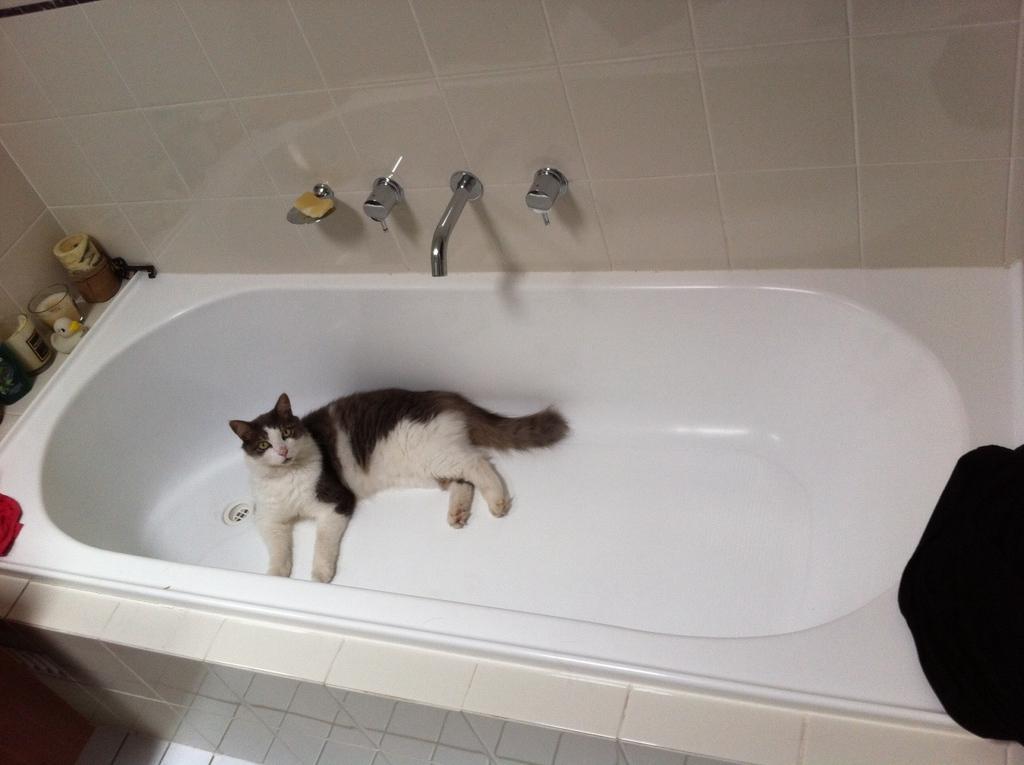Please provide a concise description of this image. In this image we can see a cat in the bathtub. We can see objects on the left side of the image. There is a black color object on the right side of the image. At the top of the image, we can see a wall. We can see tab, soap containers and holders are attached to the wall. 